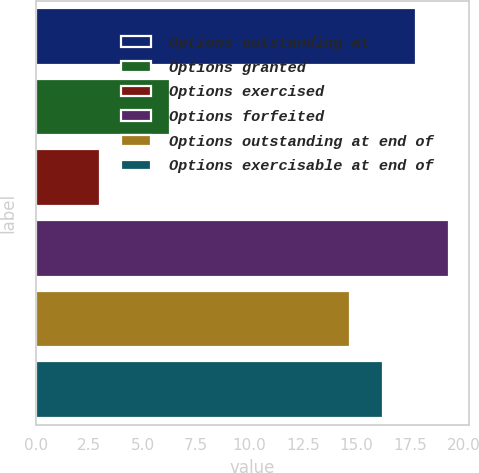Convert chart to OTSL. <chart><loc_0><loc_0><loc_500><loc_500><bar_chart><fcel>Options outstanding at<fcel>Options granted<fcel>Options exercised<fcel>Options forfeited<fcel>Options outstanding at end of<fcel>Options exercisable at end of<nl><fcel>17.77<fcel>6.28<fcel>3<fcel>19.3<fcel>14.71<fcel>16.24<nl></chart> 